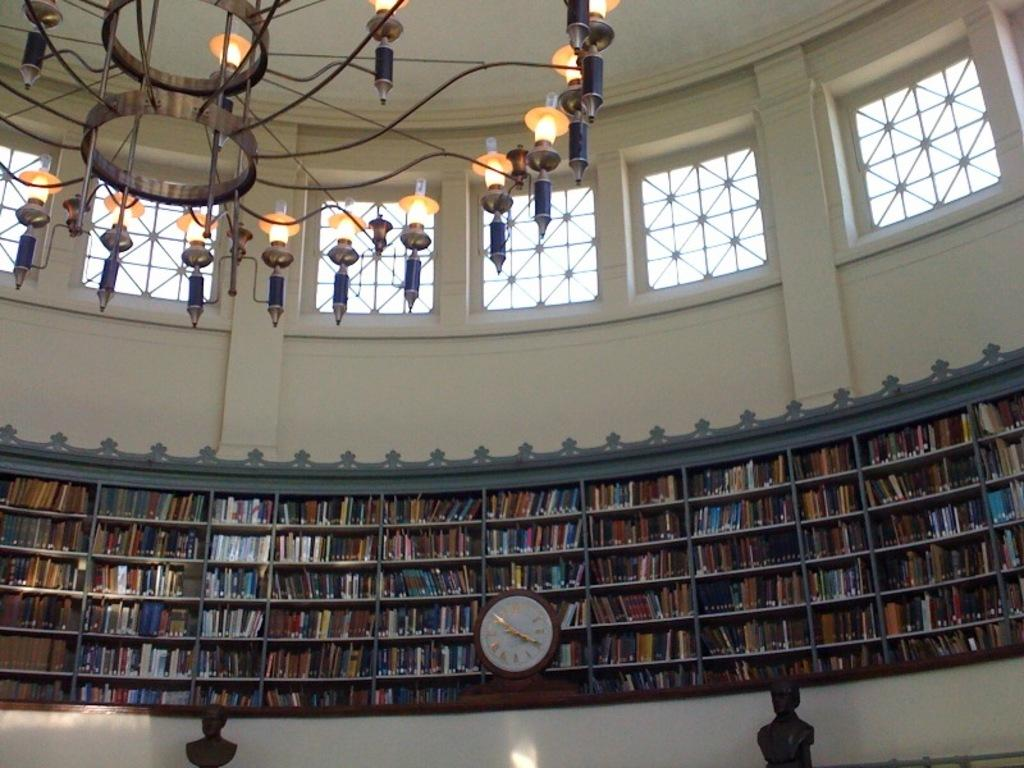What object in the image can be used to tell time? There is a clock in the image that can be used to tell time. What type of items can be seen on a shelf in the image? There are books in a shelf in the image. What is the background of the image made of? There is a wall in the image, which is likely the background. What type of lighting fixture is visible on the rooftop in the image? There is a chandelier on the rooftop in the image. What type of location might the image represent? The image may have been taken in a library, given the presence of books and a clock. What is the title of the book that the cat is reading in the image? There are no cats or books being read in the image; it only features a clock, books on a shelf, a wall, and a chandelier on the rooftop. 